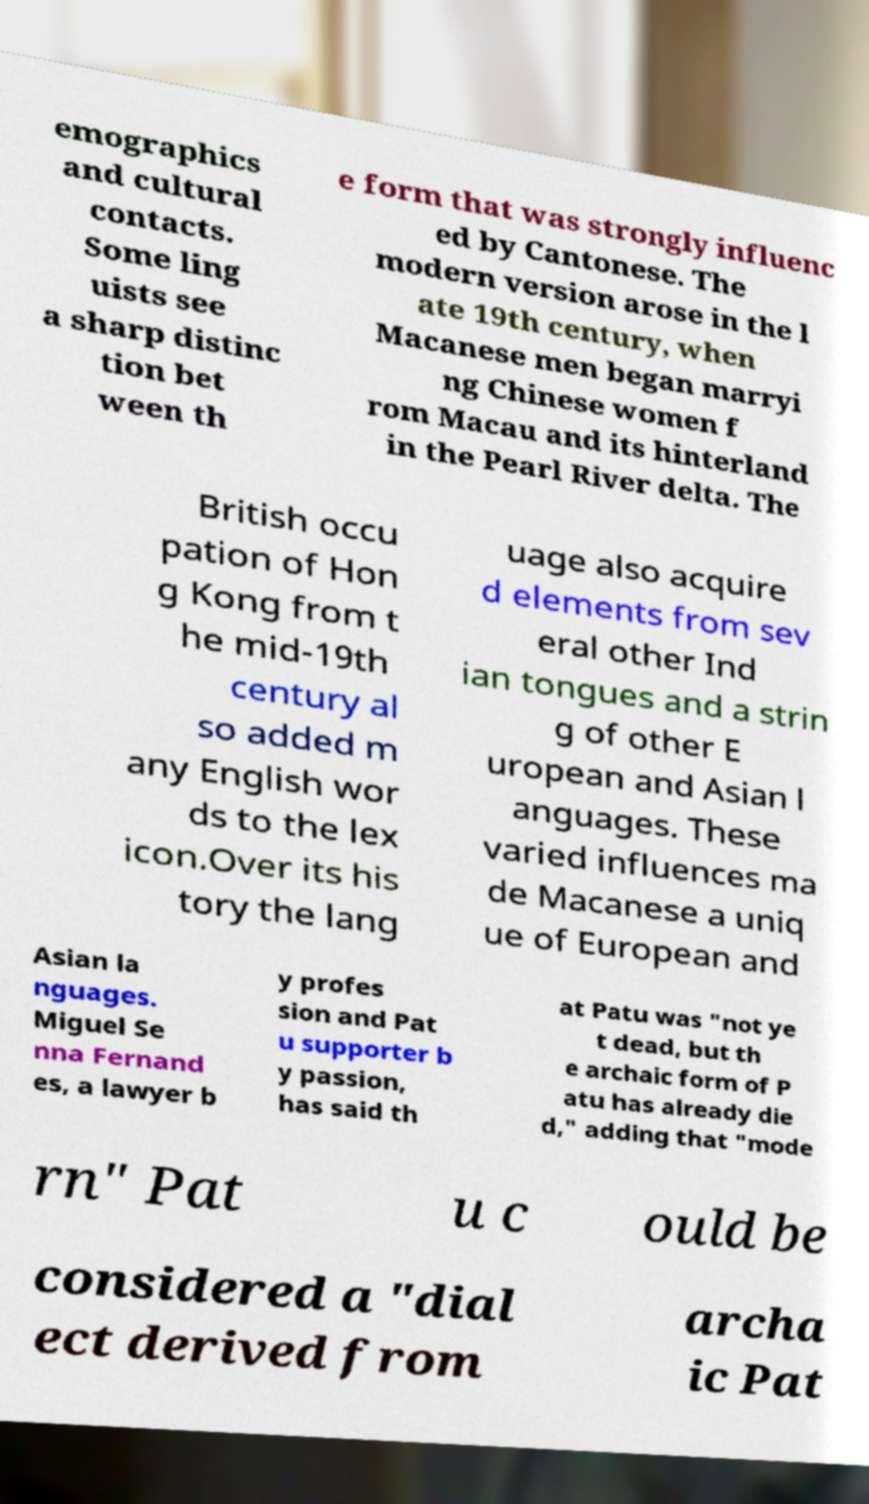What messages or text are displayed in this image? I need them in a readable, typed format. emographics and cultural contacts. Some ling uists see a sharp distinc tion bet ween th e form that was strongly influenc ed by Cantonese. The modern version arose in the l ate 19th century, when Macanese men began marryi ng Chinese women f rom Macau and its hinterland in the Pearl River delta. The British occu pation of Hon g Kong from t he mid-19th century al so added m any English wor ds to the lex icon.Over its his tory the lang uage also acquire d elements from sev eral other Ind ian tongues and a strin g of other E uropean and Asian l anguages. These varied influences ma de Macanese a uniq ue of European and Asian la nguages. Miguel Se nna Fernand es, a lawyer b y profes sion and Pat u supporter b y passion, has said th at Patu was "not ye t dead, but th e archaic form of P atu has already die d," adding that "mode rn" Pat u c ould be considered a "dial ect derived from archa ic Pat 